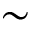<formula> <loc_0><loc_0><loc_500><loc_500>\sim</formula> 